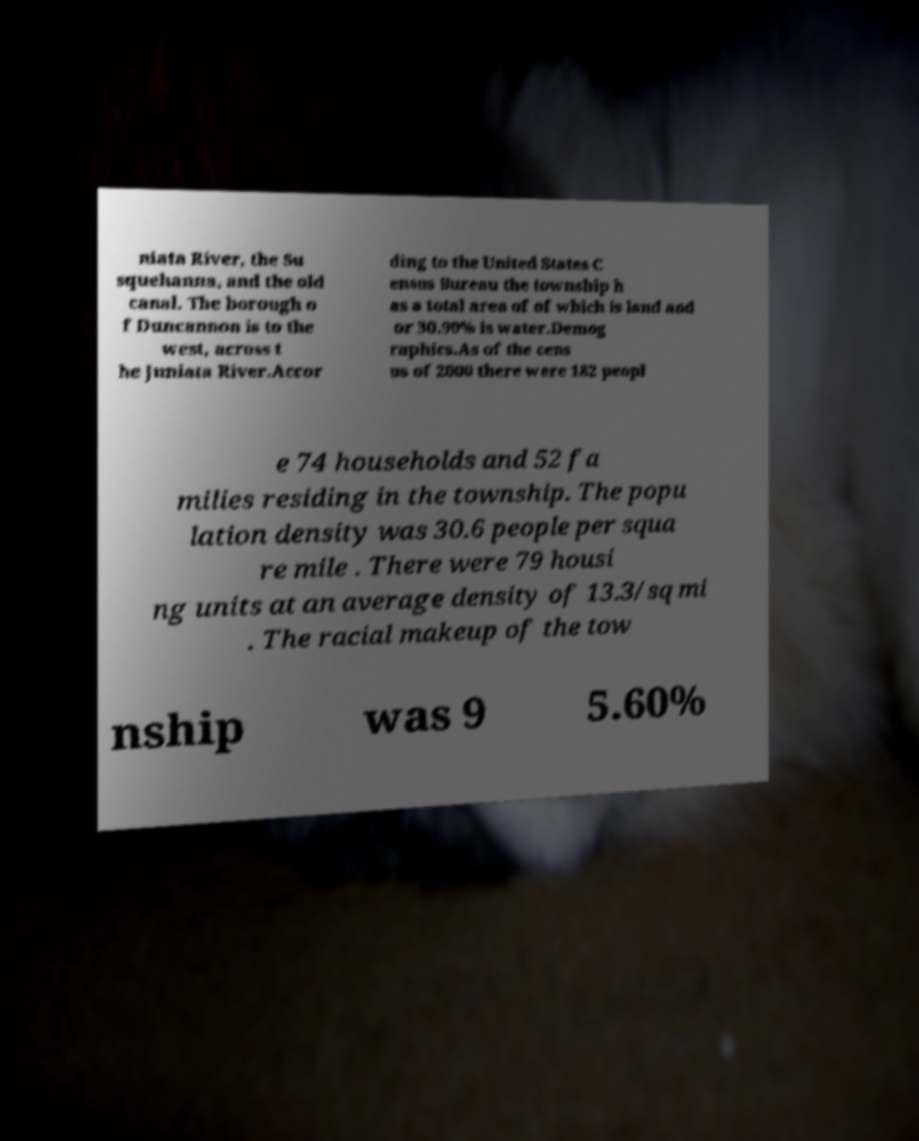Can you accurately transcribe the text from the provided image for me? niata River, the Su squehanna, and the old canal. The borough o f Duncannon is to the west, across t he Juniata River.Accor ding to the United States C ensus Bureau the township h as a total area of of which is land and or 30.90% is water.Demog raphics.As of the cens us of 2000 there were 182 peopl e 74 households and 52 fa milies residing in the township. The popu lation density was 30.6 people per squa re mile . There were 79 housi ng units at an average density of 13.3/sq mi . The racial makeup of the tow nship was 9 5.60% 